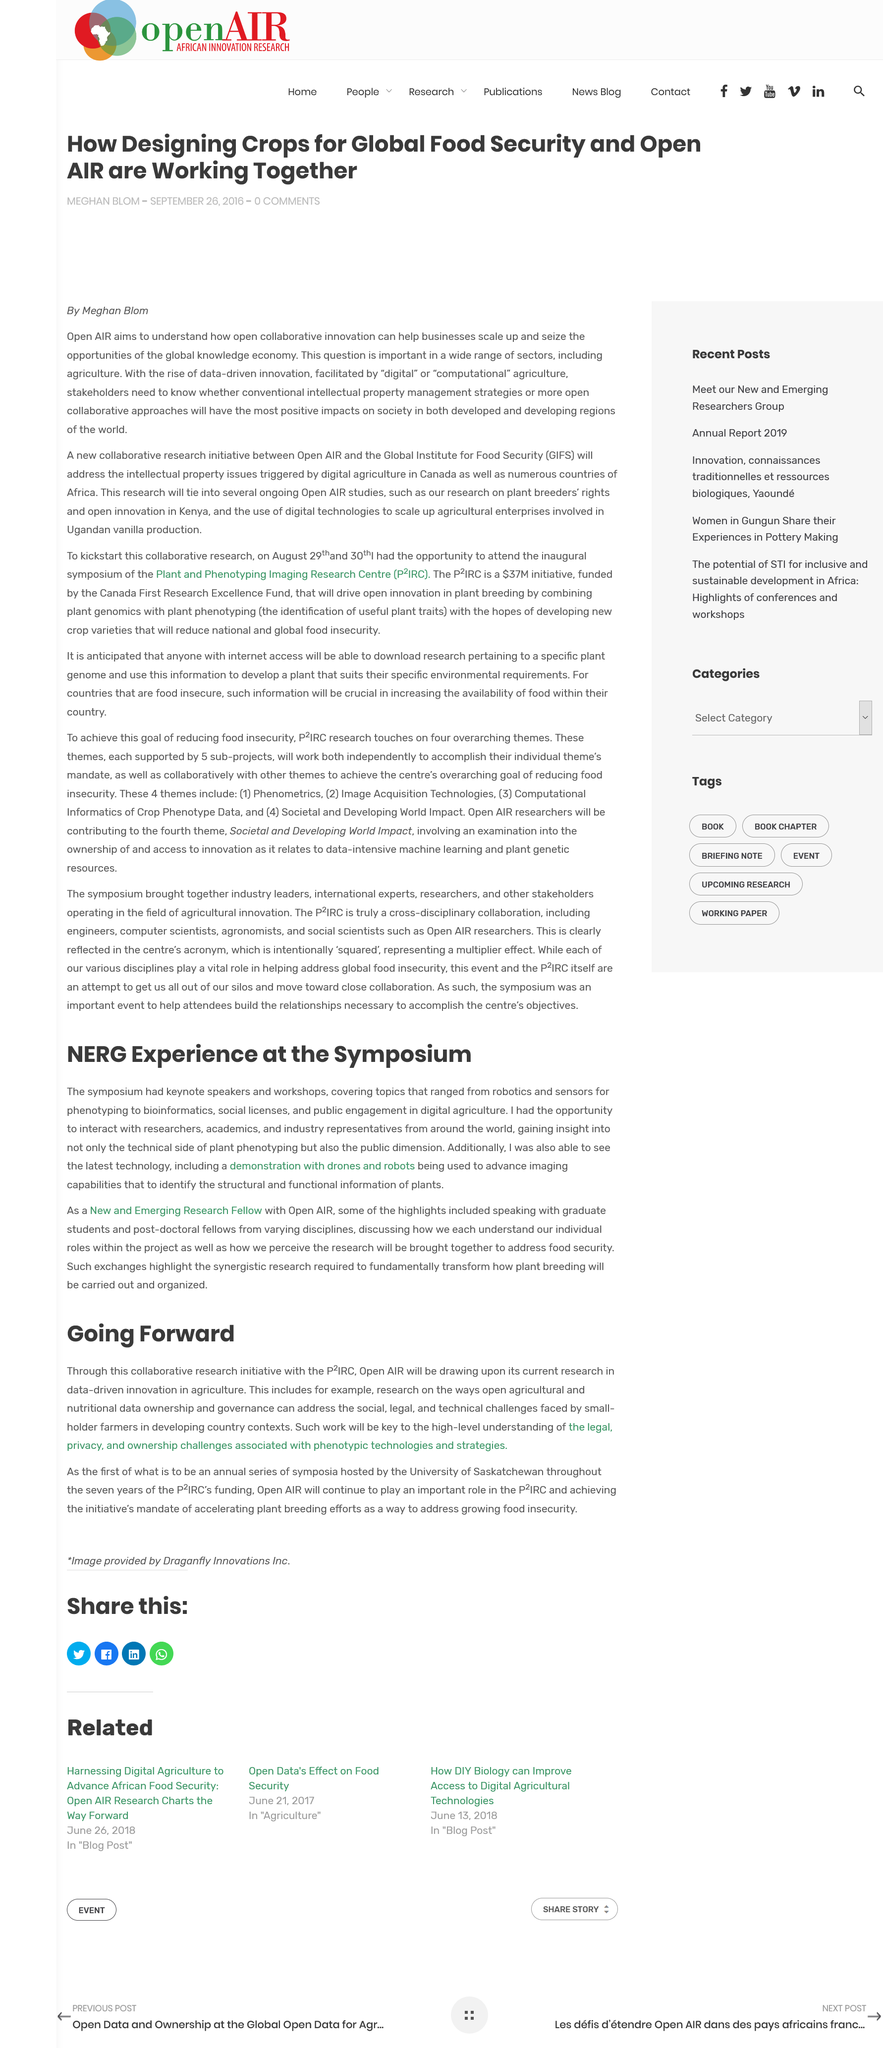Specify some key components in this picture. Yes, Saskatchewan has a university. It is being determined that plants are the subject of phenotyping. The University of Saskatchewan is hosting the first symposia. The author engaged in interactions with researchers, academics, and industry representatives. Open Air is mentioned in two paragraphs. 